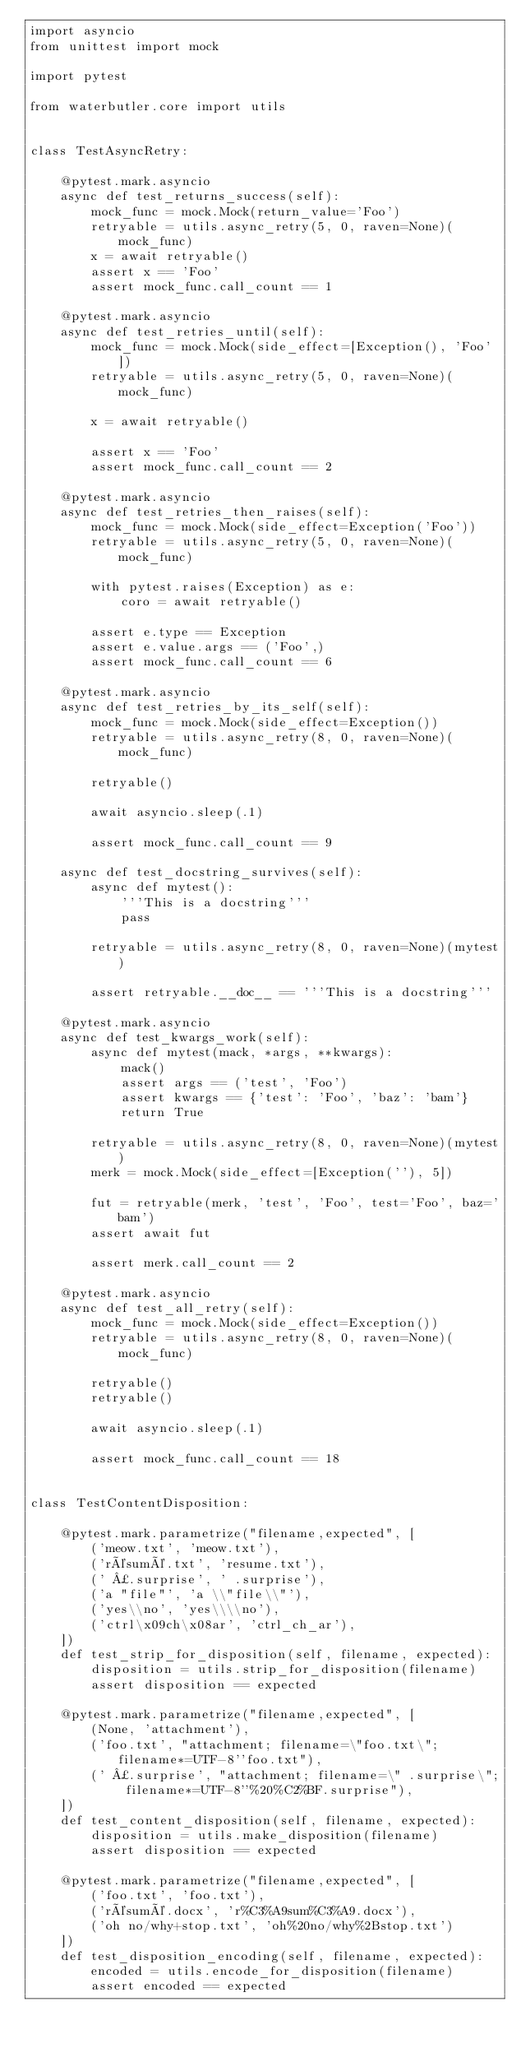Convert code to text. <code><loc_0><loc_0><loc_500><loc_500><_Python_>import asyncio
from unittest import mock

import pytest

from waterbutler.core import utils


class TestAsyncRetry:

    @pytest.mark.asyncio
    async def test_returns_success(self):
        mock_func = mock.Mock(return_value='Foo')
        retryable = utils.async_retry(5, 0, raven=None)(mock_func)
        x = await retryable()
        assert x == 'Foo'
        assert mock_func.call_count == 1

    @pytest.mark.asyncio
    async def test_retries_until(self):
        mock_func = mock.Mock(side_effect=[Exception(), 'Foo'])
        retryable = utils.async_retry(5, 0, raven=None)(mock_func)

        x = await retryable()

        assert x == 'Foo'
        assert mock_func.call_count == 2

    @pytest.mark.asyncio
    async def test_retries_then_raises(self):
        mock_func = mock.Mock(side_effect=Exception('Foo'))
        retryable = utils.async_retry(5, 0, raven=None)(mock_func)

        with pytest.raises(Exception) as e:
            coro = await retryable()

        assert e.type == Exception
        assert e.value.args == ('Foo',)
        assert mock_func.call_count == 6

    @pytest.mark.asyncio
    async def test_retries_by_its_self(self):
        mock_func = mock.Mock(side_effect=Exception())
        retryable = utils.async_retry(8, 0, raven=None)(mock_func)

        retryable()

        await asyncio.sleep(.1)

        assert mock_func.call_count == 9

    async def test_docstring_survives(self):
        async def mytest():
            '''This is a docstring'''
            pass

        retryable = utils.async_retry(8, 0, raven=None)(mytest)

        assert retryable.__doc__ == '''This is a docstring'''

    @pytest.mark.asyncio
    async def test_kwargs_work(self):
        async def mytest(mack, *args, **kwargs):
            mack()
            assert args == ('test', 'Foo')
            assert kwargs == {'test': 'Foo', 'baz': 'bam'}
            return True

        retryable = utils.async_retry(8, 0, raven=None)(mytest)
        merk = mock.Mock(side_effect=[Exception(''), 5])

        fut = retryable(merk, 'test', 'Foo', test='Foo', baz='bam')
        assert await fut

        assert merk.call_count == 2

    @pytest.mark.asyncio
    async def test_all_retry(self):
        mock_func = mock.Mock(side_effect=Exception())
        retryable = utils.async_retry(8, 0, raven=None)(mock_func)

        retryable()
        retryable()

        await asyncio.sleep(.1)

        assert mock_func.call_count == 18


class TestContentDisposition:

    @pytest.mark.parametrize("filename,expected", [
        ('meow.txt', 'meow.txt'),
        ('résumé.txt', 'resume.txt'),
        (' ¿.surprise', ' .surprise'),
        ('a "file"', 'a \\"file\\"'),
        ('yes\\no', 'yes\\\\no'),
        ('ctrl\x09ch\x08ar', 'ctrl_ch_ar'),
    ])
    def test_strip_for_disposition(self, filename, expected):
        disposition = utils.strip_for_disposition(filename)
        assert disposition == expected

    @pytest.mark.parametrize("filename,expected", [
        (None, 'attachment'),
        ('foo.txt', "attachment; filename=\"foo.txt\"; filename*=UTF-8''foo.txt"),
        (' ¿.surprise', "attachment; filename=\" .surprise\"; filename*=UTF-8''%20%C2%BF.surprise"),
    ])
    def test_content_disposition(self, filename, expected):
        disposition = utils.make_disposition(filename)
        assert disposition == expected

    @pytest.mark.parametrize("filename,expected", [
        ('foo.txt', 'foo.txt'),
        ('résumé.docx', 'r%C3%A9sum%C3%A9.docx'),
        ('oh no/why+stop.txt', 'oh%20no/why%2Bstop.txt')
    ])
    def test_disposition_encoding(self, filename, expected):
        encoded = utils.encode_for_disposition(filename)
        assert encoded == expected
</code> 